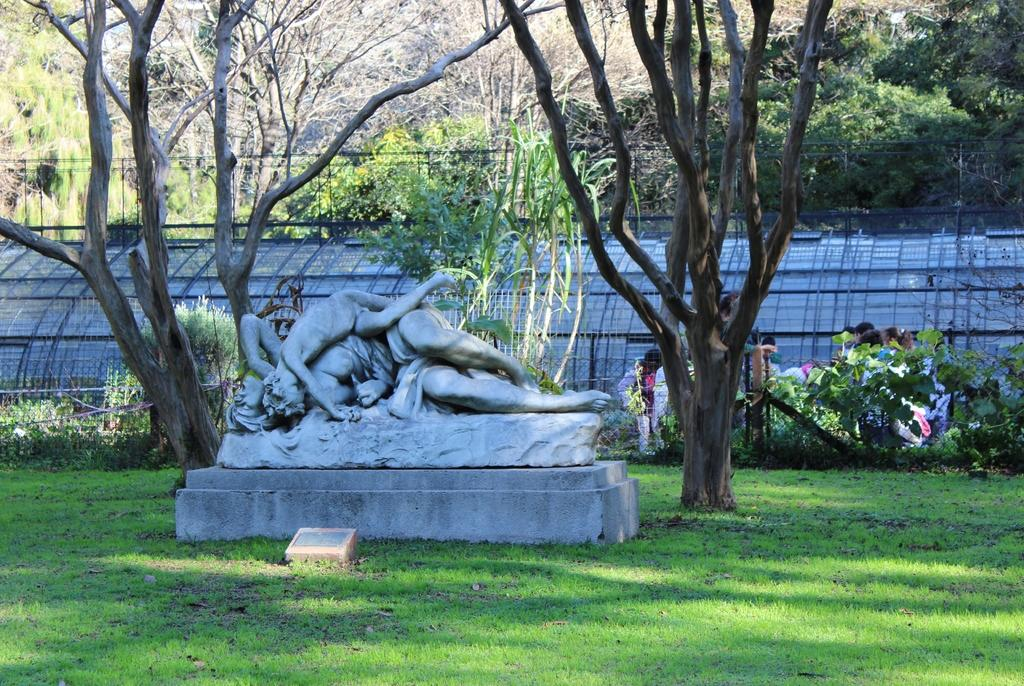What is the main subject in the center of the image? There is a statue in the center of the image. What type of vegetation can be seen in the image? There are trees in the image. What is the ground surface like at the bottom of the image? There is grass at the bottom of the image. What can be seen in the background of the image? There is fencing in the background of the image. What color of paint is used on the statue in the image? The provided facts do not mention the color of paint on the statue, so we cannot determine that information from the image. 